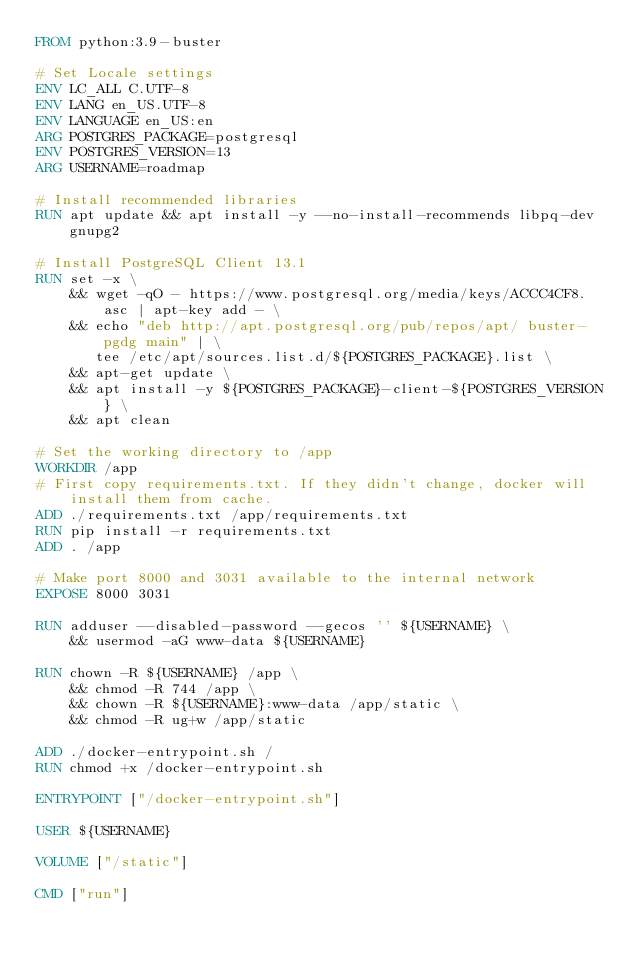<code> <loc_0><loc_0><loc_500><loc_500><_Dockerfile_>FROM python:3.9-buster

# Set Locale settings
ENV LC_ALL C.UTF-8
ENV LANG en_US.UTF-8
ENV LANGUAGE en_US:en
ARG POSTGRES_PACKAGE=postgresql
ENV POSTGRES_VERSION=13
ARG USERNAME=roadmap

# Install recommended libraries
RUN apt update && apt install -y --no-install-recommends libpq-dev gnupg2

# Install PostgreSQL Client 13.1
RUN set -x \
    && wget -qO - https://www.postgresql.org/media/keys/ACCC4CF8.asc | apt-key add - \
    && echo "deb http://apt.postgresql.org/pub/repos/apt/ buster-pgdg main" | \
       tee /etc/apt/sources.list.d/${POSTGRES_PACKAGE}.list \
    && apt-get update \
    && apt install -y ${POSTGRES_PACKAGE}-client-${POSTGRES_VERSION} \
    && apt clean

# Set the working directory to /app
WORKDIR /app
# First copy requirements.txt. If they didn't change, docker will install them from cache.
ADD ./requirements.txt /app/requirements.txt
RUN pip install -r requirements.txt
ADD . /app

# Make port 8000 and 3031 available to the internal network
EXPOSE 8000 3031

RUN adduser --disabled-password --gecos '' ${USERNAME} \
    && usermod -aG www-data ${USERNAME}

RUN chown -R ${USERNAME} /app \
    && chmod -R 744 /app \
    && chown -R ${USERNAME}:www-data /app/static \
    && chmod -R ug+w /app/static

ADD ./docker-entrypoint.sh /
RUN chmod +x /docker-entrypoint.sh

ENTRYPOINT ["/docker-entrypoint.sh"]

USER ${USERNAME}

VOLUME ["/static"]

CMD ["run"]
</code> 